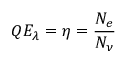<formula> <loc_0><loc_0><loc_500><loc_500>Q E _ { \lambda } = \eta = { \frac { N _ { e } } { N _ { \nu } } }</formula> 